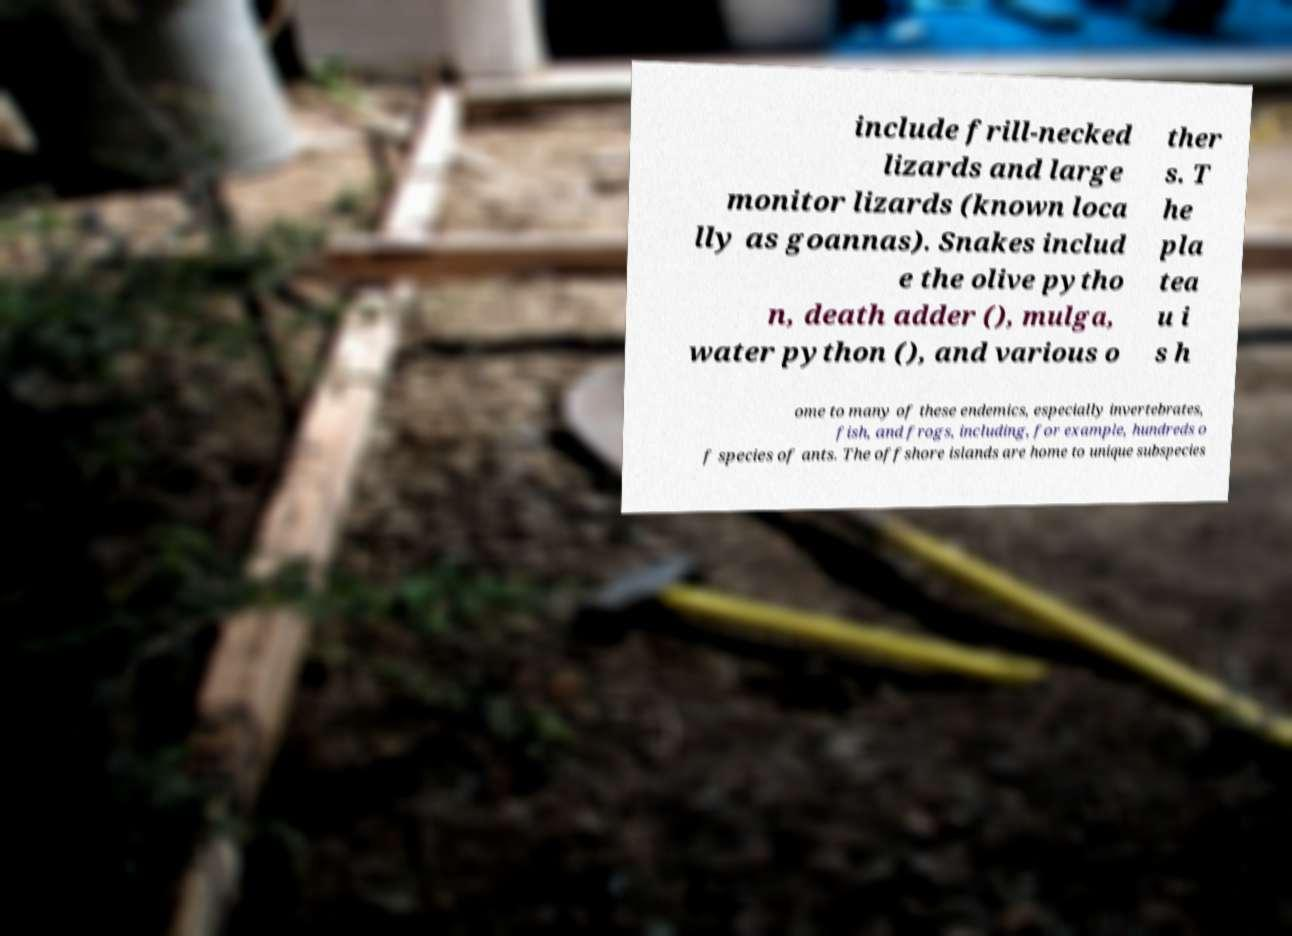Could you assist in decoding the text presented in this image and type it out clearly? include frill-necked lizards and large monitor lizards (known loca lly as goannas). Snakes includ e the olive pytho n, death adder (), mulga, water python (), and various o ther s. T he pla tea u i s h ome to many of these endemics, especially invertebrates, fish, and frogs, including, for example, hundreds o f species of ants. The offshore islands are home to unique subspecies 